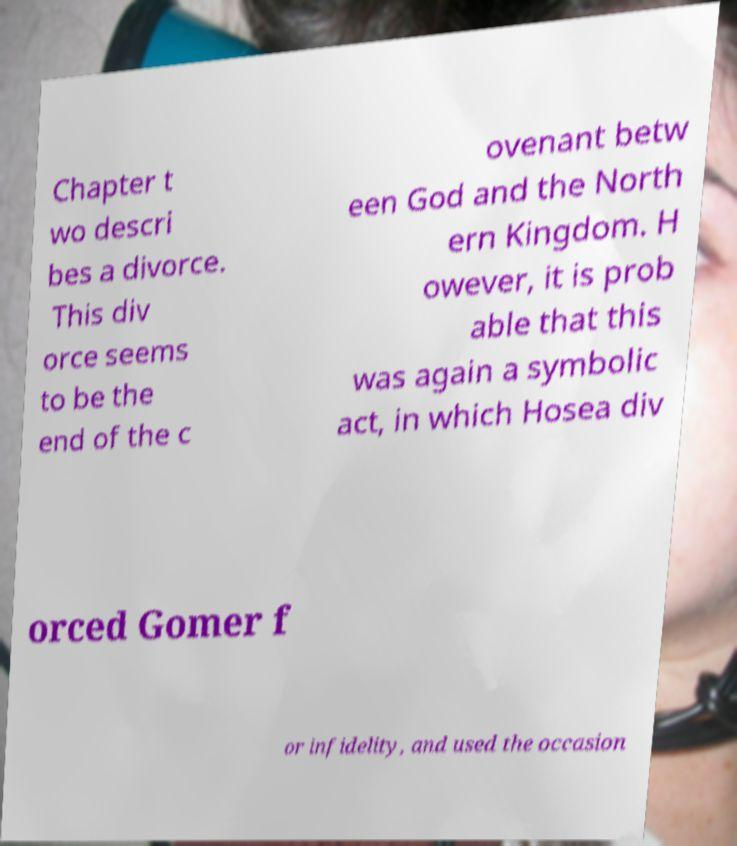Please read and relay the text visible in this image. What does it say? Chapter t wo descri bes a divorce. This div orce seems to be the end of the c ovenant betw een God and the North ern Kingdom. H owever, it is prob able that this was again a symbolic act, in which Hosea div orced Gomer f or infidelity, and used the occasion 